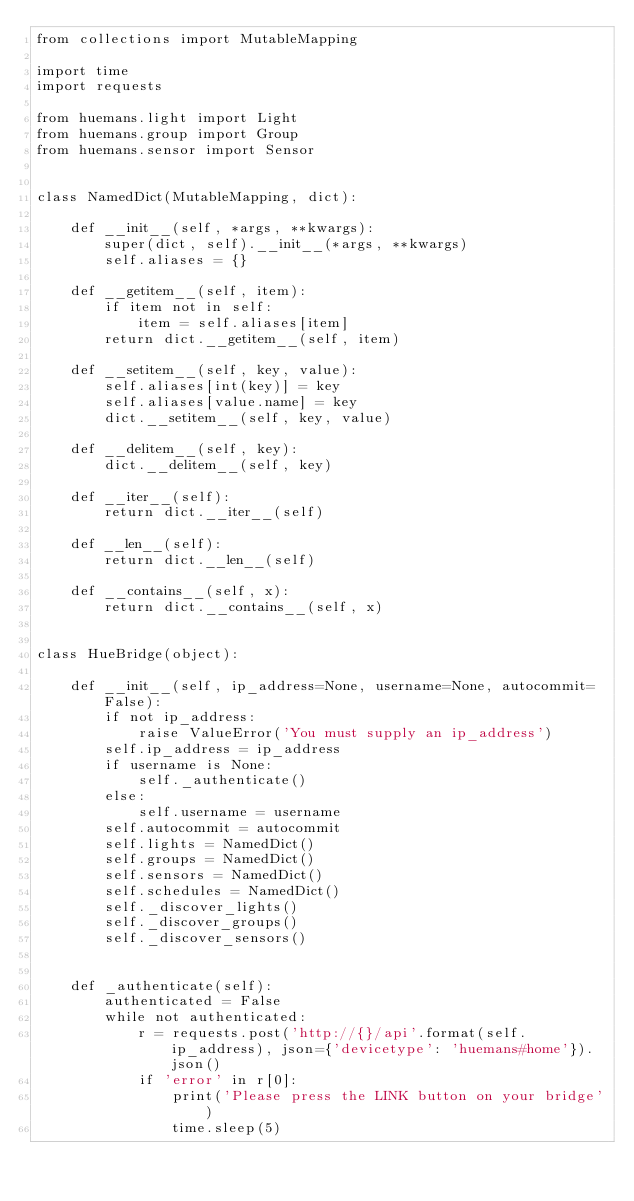<code> <loc_0><loc_0><loc_500><loc_500><_Python_>from collections import MutableMapping

import time
import requests

from huemans.light import Light
from huemans.group import Group
from huemans.sensor import Sensor


class NamedDict(MutableMapping, dict):

    def __init__(self, *args, **kwargs):
        super(dict, self).__init__(*args, **kwargs)
        self.aliases = {}

    def __getitem__(self, item):
        if item not in self:
            item = self.aliases[item]
        return dict.__getitem__(self, item)

    def __setitem__(self, key, value):
        self.aliases[int(key)] = key
        self.aliases[value.name] = key
        dict.__setitem__(self, key, value)

    def __delitem__(self, key):
        dict.__delitem__(self, key)

    def __iter__(self):
        return dict.__iter__(self)

    def __len__(self):
        return dict.__len__(self)

    def __contains__(self, x):
        return dict.__contains__(self, x)


class HueBridge(object):

    def __init__(self, ip_address=None, username=None, autocommit=False):
        if not ip_address:
            raise ValueError('You must supply an ip_address')
        self.ip_address = ip_address
        if username is None:
            self._authenticate()
        else:
            self.username = username
        self.autocommit = autocommit
        self.lights = NamedDict()
        self.groups = NamedDict()
        self.sensors = NamedDict()
        self.schedules = NamedDict()
        self._discover_lights()
        self._discover_groups()
        self._discover_sensors()


    def _authenticate(self):
        authenticated = False
        while not authenticated:
            r = requests.post('http://{}/api'.format(self.ip_address), json={'devicetype': 'huemans#home'}).json()
            if 'error' in r[0]:
                print('Please press the LINK button on your bridge')
                time.sleep(5)</code> 